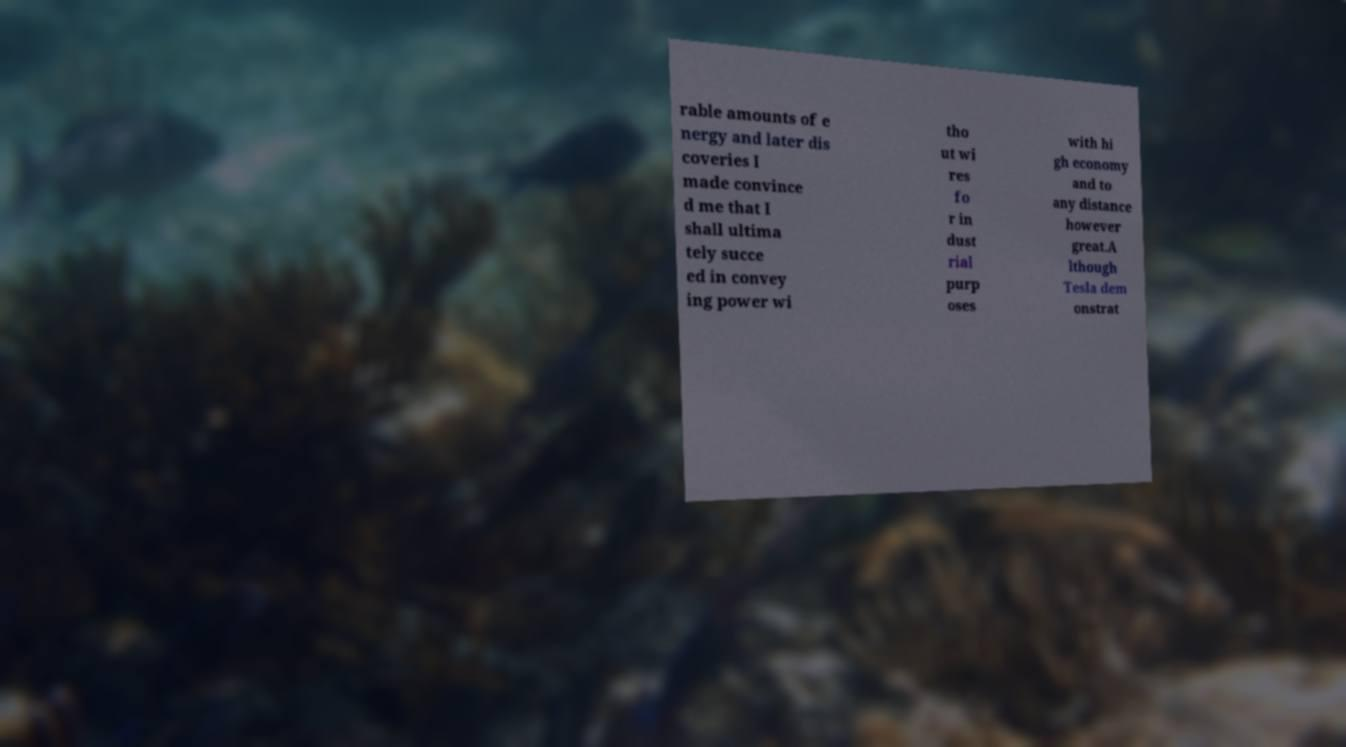Can you read and provide the text displayed in the image?This photo seems to have some interesting text. Can you extract and type it out for me? rable amounts of e nergy and later dis coveries I made convince d me that I shall ultima tely succe ed in convey ing power wi tho ut wi res fo r in dust rial purp oses with hi gh economy and to any distance however great.A lthough Tesla dem onstrat 